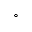<formula> <loc_0><loc_0><loc_500><loc_500>^ { \circ }</formula> 